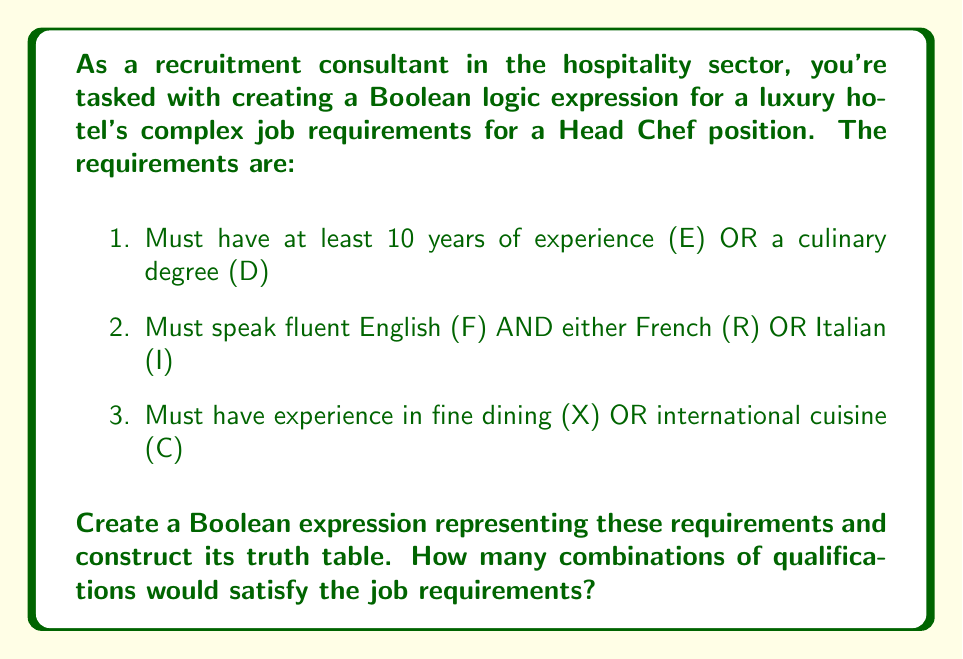Can you solve this math problem? Let's approach this step-by-step:

1. First, we need to create the Boolean expression:
   $$(E + D) \cdot (F \cdot (R + I)) \cdot (X + C)$$

2. Now, let's break down the expression into its components:
   A = $(E + D)$
   B = $(F \cdot (R + I))$
   C = $(X + C)$

   Our final expression is $A \cdot B \cdot C$

3. To construct the truth table, we need to consider all possible combinations of the variables. With 6 variables (E, D, F, R, I, X, C), we have $2^6 = 64$ rows in our truth table.

4. For each combination, we evaluate A, B, and C, then multiply the results.

5. To count the satisfying combinations, we sum up the rows where the final result is 1.

6. Here's a partial truth table to illustrate (showing only the first and last few rows):

   $$\begin{array}{ccccccc|ccc|c}
   E & D & F & R & I & X & C & A & B & C & Result \\
   \hline
   0 & 0 & 0 & 0 & 0 & 0 & 0 & 0 & 0 & 0 & 0 \\
   0 & 0 & 0 & 0 & 0 & 0 & 1 & 0 & 0 & 1 & 0 \\
   \vdots & \vdots & \vdots & \vdots & \vdots & \vdots & \vdots & \vdots & \vdots & \vdots & \vdots \\
   1 & 1 & 1 & 1 & 1 & 1 & 0 & 1 & 1 & 1 & 1 \\
   1 & 1 & 1 & 1 & 1 & 1 & 1 & 1 & 1 & 1 & 1 \\
   \end{array}$$

7. After evaluating all 64 combinations, we find that 28 combinations satisfy the job requirements.
Answer: 28 combinations 